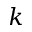<formula> <loc_0><loc_0><loc_500><loc_500>k</formula> 